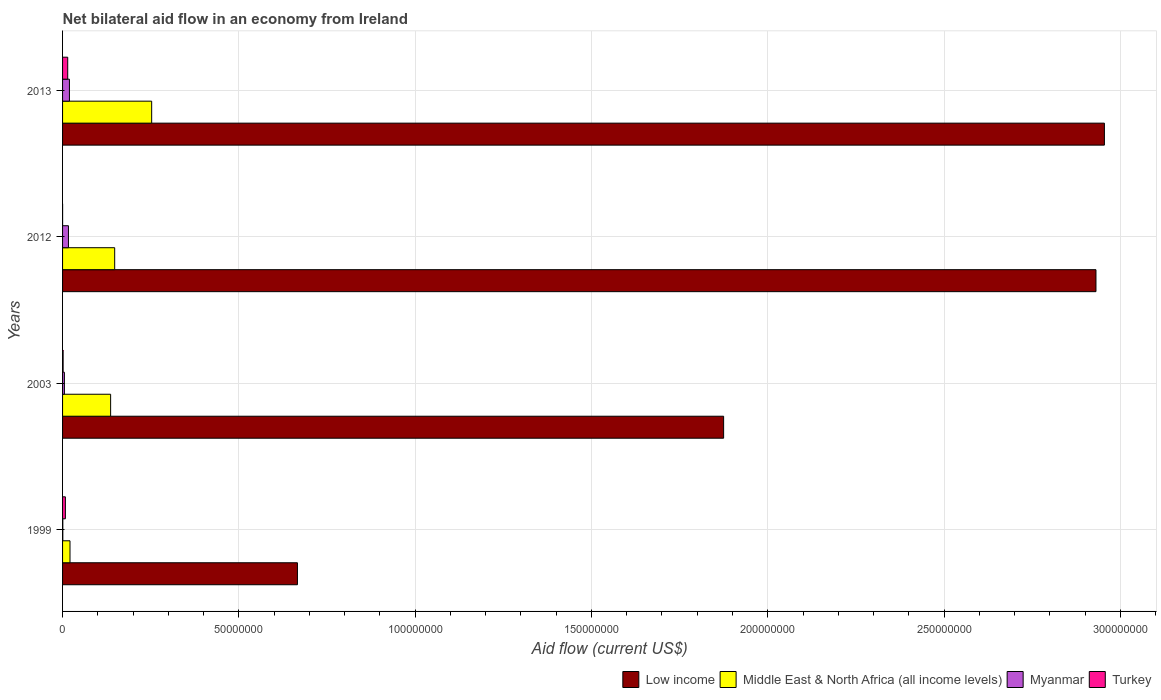How many different coloured bars are there?
Offer a very short reply. 4. How many bars are there on the 1st tick from the top?
Offer a very short reply. 4. What is the label of the 4th group of bars from the top?
Your response must be concise. 1999. What is the net bilateral aid flow in Low income in 1999?
Make the answer very short. 6.66e+07. Across all years, what is the maximum net bilateral aid flow in Turkey?
Provide a succinct answer. 1.46e+06. In which year was the net bilateral aid flow in Turkey maximum?
Your answer should be compact. 2013. In which year was the net bilateral aid flow in Turkey minimum?
Ensure brevity in your answer.  2012. What is the total net bilateral aid flow in Low income in the graph?
Your answer should be compact. 8.43e+08. What is the difference between the net bilateral aid flow in Myanmar in 1999 and that in 2003?
Your answer should be very brief. -4.50e+05. What is the difference between the net bilateral aid flow in Low income in 1999 and the net bilateral aid flow in Middle East & North Africa (all income levels) in 2012?
Ensure brevity in your answer.  5.18e+07. What is the average net bilateral aid flow in Low income per year?
Ensure brevity in your answer.  2.11e+08. In the year 2012, what is the difference between the net bilateral aid flow in Low income and net bilateral aid flow in Middle East & North Africa (all income levels)?
Keep it short and to the point. 2.78e+08. In how many years, is the net bilateral aid flow in Middle East & North Africa (all income levels) greater than 50000000 US$?
Provide a succinct answer. 0. What is the ratio of the net bilateral aid flow in Myanmar in 2012 to that in 2013?
Your response must be concise. 0.86. What is the difference between the highest and the second highest net bilateral aid flow in Myanmar?
Provide a succinct answer. 2.80e+05. What is the difference between the highest and the lowest net bilateral aid flow in Turkey?
Make the answer very short. 1.45e+06. What does the 3rd bar from the top in 2003 represents?
Keep it short and to the point. Middle East & North Africa (all income levels). What does the 3rd bar from the bottom in 2003 represents?
Give a very brief answer. Myanmar. How many bars are there?
Provide a succinct answer. 16. How many years are there in the graph?
Your answer should be compact. 4. What is the difference between two consecutive major ticks on the X-axis?
Give a very brief answer. 5.00e+07. Are the values on the major ticks of X-axis written in scientific E-notation?
Keep it short and to the point. No. How are the legend labels stacked?
Keep it short and to the point. Horizontal. What is the title of the graph?
Your response must be concise. Net bilateral aid flow in an economy from Ireland. Does "Virgin Islands" appear as one of the legend labels in the graph?
Offer a terse response. No. What is the label or title of the Y-axis?
Keep it short and to the point. Years. What is the Aid flow (current US$) of Low income in 1999?
Make the answer very short. 6.66e+07. What is the Aid flow (current US$) of Middle East & North Africa (all income levels) in 1999?
Provide a succinct answer. 2.11e+06. What is the Aid flow (current US$) of Myanmar in 1999?
Keep it short and to the point. 7.00e+04. What is the Aid flow (current US$) in Turkey in 1999?
Your answer should be very brief. 8.00e+05. What is the Aid flow (current US$) in Low income in 2003?
Ensure brevity in your answer.  1.87e+08. What is the Aid flow (current US$) of Middle East & North Africa (all income levels) in 2003?
Offer a very short reply. 1.36e+07. What is the Aid flow (current US$) of Myanmar in 2003?
Your answer should be compact. 5.20e+05. What is the Aid flow (current US$) of Turkey in 2003?
Offer a very short reply. 1.60e+05. What is the Aid flow (current US$) in Low income in 2012?
Make the answer very short. 2.93e+08. What is the Aid flow (current US$) in Middle East & North Africa (all income levels) in 2012?
Offer a terse response. 1.48e+07. What is the Aid flow (current US$) in Myanmar in 2012?
Ensure brevity in your answer.  1.67e+06. What is the Aid flow (current US$) of Low income in 2013?
Keep it short and to the point. 2.95e+08. What is the Aid flow (current US$) in Middle East & North Africa (all income levels) in 2013?
Ensure brevity in your answer.  2.53e+07. What is the Aid flow (current US$) in Myanmar in 2013?
Make the answer very short. 1.95e+06. What is the Aid flow (current US$) of Turkey in 2013?
Offer a terse response. 1.46e+06. Across all years, what is the maximum Aid flow (current US$) of Low income?
Your answer should be compact. 2.95e+08. Across all years, what is the maximum Aid flow (current US$) of Middle East & North Africa (all income levels)?
Your answer should be very brief. 2.53e+07. Across all years, what is the maximum Aid flow (current US$) in Myanmar?
Ensure brevity in your answer.  1.95e+06. Across all years, what is the maximum Aid flow (current US$) of Turkey?
Offer a terse response. 1.46e+06. Across all years, what is the minimum Aid flow (current US$) in Low income?
Ensure brevity in your answer.  6.66e+07. Across all years, what is the minimum Aid flow (current US$) of Middle East & North Africa (all income levels)?
Keep it short and to the point. 2.11e+06. Across all years, what is the minimum Aid flow (current US$) of Turkey?
Your response must be concise. 10000. What is the total Aid flow (current US$) in Low income in the graph?
Provide a succinct answer. 8.43e+08. What is the total Aid flow (current US$) of Middle East & North Africa (all income levels) in the graph?
Give a very brief answer. 5.58e+07. What is the total Aid flow (current US$) in Myanmar in the graph?
Offer a terse response. 4.21e+06. What is the total Aid flow (current US$) in Turkey in the graph?
Your answer should be compact. 2.43e+06. What is the difference between the Aid flow (current US$) in Low income in 1999 and that in 2003?
Your answer should be very brief. -1.21e+08. What is the difference between the Aid flow (current US$) in Middle East & North Africa (all income levels) in 1999 and that in 2003?
Make the answer very short. -1.15e+07. What is the difference between the Aid flow (current US$) in Myanmar in 1999 and that in 2003?
Provide a succinct answer. -4.50e+05. What is the difference between the Aid flow (current US$) of Turkey in 1999 and that in 2003?
Keep it short and to the point. 6.40e+05. What is the difference between the Aid flow (current US$) in Low income in 1999 and that in 2012?
Make the answer very short. -2.26e+08. What is the difference between the Aid flow (current US$) of Middle East & North Africa (all income levels) in 1999 and that in 2012?
Offer a very short reply. -1.27e+07. What is the difference between the Aid flow (current US$) of Myanmar in 1999 and that in 2012?
Give a very brief answer. -1.60e+06. What is the difference between the Aid flow (current US$) in Turkey in 1999 and that in 2012?
Your answer should be very brief. 7.90e+05. What is the difference between the Aid flow (current US$) of Low income in 1999 and that in 2013?
Ensure brevity in your answer.  -2.29e+08. What is the difference between the Aid flow (current US$) of Middle East & North Africa (all income levels) in 1999 and that in 2013?
Give a very brief answer. -2.32e+07. What is the difference between the Aid flow (current US$) of Myanmar in 1999 and that in 2013?
Offer a very short reply. -1.88e+06. What is the difference between the Aid flow (current US$) in Turkey in 1999 and that in 2013?
Provide a short and direct response. -6.60e+05. What is the difference between the Aid flow (current US$) of Low income in 2003 and that in 2012?
Offer a very short reply. -1.06e+08. What is the difference between the Aid flow (current US$) in Middle East & North Africa (all income levels) in 2003 and that in 2012?
Provide a succinct answer. -1.15e+06. What is the difference between the Aid flow (current US$) in Myanmar in 2003 and that in 2012?
Provide a short and direct response. -1.15e+06. What is the difference between the Aid flow (current US$) of Low income in 2003 and that in 2013?
Your answer should be compact. -1.08e+08. What is the difference between the Aid flow (current US$) of Middle East & North Africa (all income levels) in 2003 and that in 2013?
Your answer should be very brief. -1.16e+07. What is the difference between the Aid flow (current US$) of Myanmar in 2003 and that in 2013?
Keep it short and to the point. -1.43e+06. What is the difference between the Aid flow (current US$) in Turkey in 2003 and that in 2013?
Your answer should be compact. -1.30e+06. What is the difference between the Aid flow (current US$) in Low income in 2012 and that in 2013?
Make the answer very short. -2.39e+06. What is the difference between the Aid flow (current US$) of Middle East & North Africa (all income levels) in 2012 and that in 2013?
Provide a succinct answer. -1.05e+07. What is the difference between the Aid flow (current US$) of Myanmar in 2012 and that in 2013?
Provide a short and direct response. -2.80e+05. What is the difference between the Aid flow (current US$) of Turkey in 2012 and that in 2013?
Keep it short and to the point. -1.45e+06. What is the difference between the Aid flow (current US$) in Low income in 1999 and the Aid flow (current US$) in Middle East & North Africa (all income levels) in 2003?
Offer a very short reply. 5.30e+07. What is the difference between the Aid flow (current US$) in Low income in 1999 and the Aid flow (current US$) in Myanmar in 2003?
Provide a succinct answer. 6.61e+07. What is the difference between the Aid flow (current US$) in Low income in 1999 and the Aid flow (current US$) in Turkey in 2003?
Keep it short and to the point. 6.64e+07. What is the difference between the Aid flow (current US$) in Middle East & North Africa (all income levels) in 1999 and the Aid flow (current US$) in Myanmar in 2003?
Your response must be concise. 1.59e+06. What is the difference between the Aid flow (current US$) in Middle East & North Africa (all income levels) in 1999 and the Aid flow (current US$) in Turkey in 2003?
Keep it short and to the point. 1.95e+06. What is the difference between the Aid flow (current US$) in Low income in 1999 and the Aid flow (current US$) in Middle East & North Africa (all income levels) in 2012?
Your answer should be very brief. 5.18e+07. What is the difference between the Aid flow (current US$) of Low income in 1999 and the Aid flow (current US$) of Myanmar in 2012?
Provide a succinct answer. 6.49e+07. What is the difference between the Aid flow (current US$) of Low income in 1999 and the Aid flow (current US$) of Turkey in 2012?
Offer a terse response. 6.66e+07. What is the difference between the Aid flow (current US$) of Middle East & North Africa (all income levels) in 1999 and the Aid flow (current US$) of Myanmar in 2012?
Your answer should be very brief. 4.40e+05. What is the difference between the Aid flow (current US$) in Middle East & North Africa (all income levels) in 1999 and the Aid flow (current US$) in Turkey in 2012?
Keep it short and to the point. 2.10e+06. What is the difference between the Aid flow (current US$) in Myanmar in 1999 and the Aid flow (current US$) in Turkey in 2012?
Your response must be concise. 6.00e+04. What is the difference between the Aid flow (current US$) in Low income in 1999 and the Aid flow (current US$) in Middle East & North Africa (all income levels) in 2013?
Provide a succinct answer. 4.13e+07. What is the difference between the Aid flow (current US$) in Low income in 1999 and the Aid flow (current US$) in Myanmar in 2013?
Provide a short and direct response. 6.47e+07. What is the difference between the Aid flow (current US$) of Low income in 1999 and the Aid flow (current US$) of Turkey in 2013?
Your answer should be very brief. 6.52e+07. What is the difference between the Aid flow (current US$) of Middle East & North Africa (all income levels) in 1999 and the Aid flow (current US$) of Myanmar in 2013?
Ensure brevity in your answer.  1.60e+05. What is the difference between the Aid flow (current US$) of Middle East & North Africa (all income levels) in 1999 and the Aid flow (current US$) of Turkey in 2013?
Provide a short and direct response. 6.50e+05. What is the difference between the Aid flow (current US$) in Myanmar in 1999 and the Aid flow (current US$) in Turkey in 2013?
Provide a succinct answer. -1.39e+06. What is the difference between the Aid flow (current US$) in Low income in 2003 and the Aid flow (current US$) in Middle East & North Africa (all income levels) in 2012?
Offer a very short reply. 1.73e+08. What is the difference between the Aid flow (current US$) of Low income in 2003 and the Aid flow (current US$) of Myanmar in 2012?
Make the answer very short. 1.86e+08. What is the difference between the Aid flow (current US$) in Low income in 2003 and the Aid flow (current US$) in Turkey in 2012?
Make the answer very short. 1.87e+08. What is the difference between the Aid flow (current US$) in Middle East & North Africa (all income levels) in 2003 and the Aid flow (current US$) in Myanmar in 2012?
Provide a short and direct response. 1.20e+07. What is the difference between the Aid flow (current US$) of Middle East & North Africa (all income levels) in 2003 and the Aid flow (current US$) of Turkey in 2012?
Make the answer very short. 1.36e+07. What is the difference between the Aid flow (current US$) of Myanmar in 2003 and the Aid flow (current US$) of Turkey in 2012?
Provide a succinct answer. 5.10e+05. What is the difference between the Aid flow (current US$) of Low income in 2003 and the Aid flow (current US$) of Middle East & North Africa (all income levels) in 2013?
Your answer should be very brief. 1.62e+08. What is the difference between the Aid flow (current US$) in Low income in 2003 and the Aid flow (current US$) in Myanmar in 2013?
Provide a succinct answer. 1.86e+08. What is the difference between the Aid flow (current US$) of Low income in 2003 and the Aid flow (current US$) of Turkey in 2013?
Offer a very short reply. 1.86e+08. What is the difference between the Aid flow (current US$) of Middle East & North Africa (all income levels) in 2003 and the Aid flow (current US$) of Myanmar in 2013?
Your answer should be compact. 1.17e+07. What is the difference between the Aid flow (current US$) in Middle East & North Africa (all income levels) in 2003 and the Aid flow (current US$) in Turkey in 2013?
Ensure brevity in your answer.  1.22e+07. What is the difference between the Aid flow (current US$) in Myanmar in 2003 and the Aid flow (current US$) in Turkey in 2013?
Ensure brevity in your answer.  -9.40e+05. What is the difference between the Aid flow (current US$) of Low income in 2012 and the Aid flow (current US$) of Middle East & North Africa (all income levels) in 2013?
Offer a terse response. 2.68e+08. What is the difference between the Aid flow (current US$) in Low income in 2012 and the Aid flow (current US$) in Myanmar in 2013?
Ensure brevity in your answer.  2.91e+08. What is the difference between the Aid flow (current US$) of Low income in 2012 and the Aid flow (current US$) of Turkey in 2013?
Offer a terse response. 2.92e+08. What is the difference between the Aid flow (current US$) in Middle East & North Africa (all income levels) in 2012 and the Aid flow (current US$) in Myanmar in 2013?
Offer a very short reply. 1.28e+07. What is the difference between the Aid flow (current US$) of Middle East & North Africa (all income levels) in 2012 and the Aid flow (current US$) of Turkey in 2013?
Your answer should be very brief. 1.33e+07. What is the difference between the Aid flow (current US$) in Myanmar in 2012 and the Aid flow (current US$) in Turkey in 2013?
Your answer should be compact. 2.10e+05. What is the average Aid flow (current US$) in Low income per year?
Ensure brevity in your answer.  2.11e+08. What is the average Aid flow (current US$) of Middle East & North Africa (all income levels) per year?
Your response must be concise. 1.39e+07. What is the average Aid flow (current US$) in Myanmar per year?
Offer a very short reply. 1.05e+06. What is the average Aid flow (current US$) of Turkey per year?
Your answer should be very brief. 6.08e+05. In the year 1999, what is the difference between the Aid flow (current US$) of Low income and Aid flow (current US$) of Middle East & North Africa (all income levels)?
Provide a short and direct response. 6.45e+07. In the year 1999, what is the difference between the Aid flow (current US$) of Low income and Aid flow (current US$) of Myanmar?
Your response must be concise. 6.65e+07. In the year 1999, what is the difference between the Aid flow (current US$) in Low income and Aid flow (current US$) in Turkey?
Offer a very short reply. 6.58e+07. In the year 1999, what is the difference between the Aid flow (current US$) of Middle East & North Africa (all income levels) and Aid flow (current US$) of Myanmar?
Provide a succinct answer. 2.04e+06. In the year 1999, what is the difference between the Aid flow (current US$) in Middle East & North Africa (all income levels) and Aid flow (current US$) in Turkey?
Make the answer very short. 1.31e+06. In the year 1999, what is the difference between the Aid flow (current US$) of Myanmar and Aid flow (current US$) of Turkey?
Offer a very short reply. -7.30e+05. In the year 2003, what is the difference between the Aid flow (current US$) in Low income and Aid flow (current US$) in Middle East & North Africa (all income levels)?
Make the answer very short. 1.74e+08. In the year 2003, what is the difference between the Aid flow (current US$) in Low income and Aid flow (current US$) in Myanmar?
Ensure brevity in your answer.  1.87e+08. In the year 2003, what is the difference between the Aid flow (current US$) in Low income and Aid flow (current US$) in Turkey?
Provide a short and direct response. 1.87e+08. In the year 2003, what is the difference between the Aid flow (current US$) of Middle East & North Africa (all income levels) and Aid flow (current US$) of Myanmar?
Keep it short and to the point. 1.31e+07. In the year 2003, what is the difference between the Aid flow (current US$) of Middle East & North Africa (all income levels) and Aid flow (current US$) of Turkey?
Your response must be concise. 1.35e+07. In the year 2012, what is the difference between the Aid flow (current US$) in Low income and Aid flow (current US$) in Middle East & North Africa (all income levels)?
Ensure brevity in your answer.  2.78e+08. In the year 2012, what is the difference between the Aid flow (current US$) in Low income and Aid flow (current US$) in Myanmar?
Provide a short and direct response. 2.91e+08. In the year 2012, what is the difference between the Aid flow (current US$) in Low income and Aid flow (current US$) in Turkey?
Your response must be concise. 2.93e+08. In the year 2012, what is the difference between the Aid flow (current US$) of Middle East & North Africa (all income levels) and Aid flow (current US$) of Myanmar?
Ensure brevity in your answer.  1.31e+07. In the year 2012, what is the difference between the Aid flow (current US$) in Middle East & North Africa (all income levels) and Aid flow (current US$) in Turkey?
Give a very brief answer. 1.48e+07. In the year 2012, what is the difference between the Aid flow (current US$) in Myanmar and Aid flow (current US$) in Turkey?
Give a very brief answer. 1.66e+06. In the year 2013, what is the difference between the Aid flow (current US$) of Low income and Aid flow (current US$) of Middle East & North Africa (all income levels)?
Ensure brevity in your answer.  2.70e+08. In the year 2013, what is the difference between the Aid flow (current US$) of Low income and Aid flow (current US$) of Myanmar?
Make the answer very short. 2.94e+08. In the year 2013, what is the difference between the Aid flow (current US$) of Low income and Aid flow (current US$) of Turkey?
Keep it short and to the point. 2.94e+08. In the year 2013, what is the difference between the Aid flow (current US$) in Middle East & North Africa (all income levels) and Aid flow (current US$) in Myanmar?
Make the answer very short. 2.33e+07. In the year 2013, what is the difference between the Aid flow (current US$) of Middle East & North Africa (all income levels) and Aid flow (current US$) of Turkey?
Offer a very short reply. 2.38e+07. In the year 2013, what is the difference between the Aid flow (current US$) of Myanmar and Aid flow (current US$) of Turkey?
Your answer should be very brief. 4.90e+05. What is the ratio of the Aid flow (current US$) of Low income in 1999 to that in 2003?
Provide a succinct answer. 0.36. What is the ratio of the Aid flow (current US$) in Middle East & North Africa (all income levels) in 1999 to that in 2003?
Offer a very short reply. 0.15. What is the ratio of the Aid flow (current US$) in Myanmar in 1999 to that in 2003?
Give a very brief answer. 0.13. What is the ratio of the Aid flow (current US$) in Low income in 1999 to that in 2012?
Give a very brief answer. 0.23. What is the ratio of the Aid flow (current US$) in Middle East & North Africa (all income levels) in 1999 to that in 2012?
Your answer should be very brief. 0.14. What is the ratio of the Aid flow (current US$) in Myanmar in 1999 to that in 2012?
Ensure brevity in your answer.  0.04. What is the ratio of the Aid flow (current US$) in Low income in 1999 to that in 2013?
Offer a terse response. 0.23. What is the ratio of the Aid flow (current US$) of Middle East & North Africa (all income levels) in 1999 to that in 2013?
Your answer should be very brief. 0.08. What is the ratio of the Aid flow (current US$) in Myanmar in 1999 to that in 2013?
Offer a very short reply. 0.04. What is the ratio of the Aid flow (current US$) of Turkey in 1999 to that in 2013?
Keep it short and to the point. 0.55. What is the ratio of the Aid flow (current US$) of Low income in 2003 to that in 2012?
Offer a very short reply. 0.64. What is the ratio of the Aid flow (current US$) in Middle East & North Africa (all income levels) in 2003 to that in 2012?
Provide a short and direct response. 0.92. What is the ratio of the Aid flow (current US$) of Myanmar in 2003 to that in 2012?
Make the answer very short. 0.31. What is the ratio of the Aid flow (current US$) in Turkey in 2003 to that in 2012?
Provide a succinct answer. 16. What is the ratio of the Aid flow (current US$) in Low income in 2003 to that in 2013?
Give a very brief answer. 0.63. What is the ratio of the Aid flow (current US$) in Middle East & North Africa (all income levels) in 2003 to that in 2013?
Give a very brief answer. 0.54. What is the ratio of the Aid flow (current US$) of Myanmar in 2003 to that in 2013?
Provide a succinct answer. 0.27. What is the ratio of the Aid flow (current US$) of Turkey in 2003 to that in 2013?
Provide a short and direct response. 0.11. What is the ratio of the Aid flow (current US$) in Low income in 2012 to that in 2013?
Ensure brevity in your answer.  0.99. What is the ratio of the Aid flow (current US$) of Middle East & North Africa (all income levels) in 2012 to that in 2013?
Make the answer very short. 0.58. What is the ratio of the Aid flow (current US$) of Myanmar in 2012 to that in 2013?
Your response must be concise. 0.86. What is the ratio of the Aid flow (current US$) of Turkey in 2012 to that in 2013?
Ensure brevity in your answer.  0.01. What is the difference between the highest and the second highest Aid flow (current US$) in Low income?
Give a very brief answer. 2.39e+06. What is the difference between the highest and the second highest Aid flow (current US$) of Middle East & North Africa (all income levels)?
Offer a terse response. 1.05e+07. What is the difference between the highest and the second highest Aid flow (current US$) in Myanmar?
Your answer should be compact. 2.80e+05. What is the difference between the highest and the lowest Aid flow (current US$) in Low income?
Your answer should be very brief. 2.29e+08. What is the difference between the highest and the lowest Aid flow (current US$) of Middle East & North Africa (all income levels)?
Your answer should be very brief. 2.32e+07. What is the difference between the highest and the lowest Aid flow (current US$) in Myanmar?
Offer a terse response. 1.88e+06. What is the difference between the highest and the lowest Aid flow (current US$) of Turkey?
Give a very brief answer. 1.45e+06. 